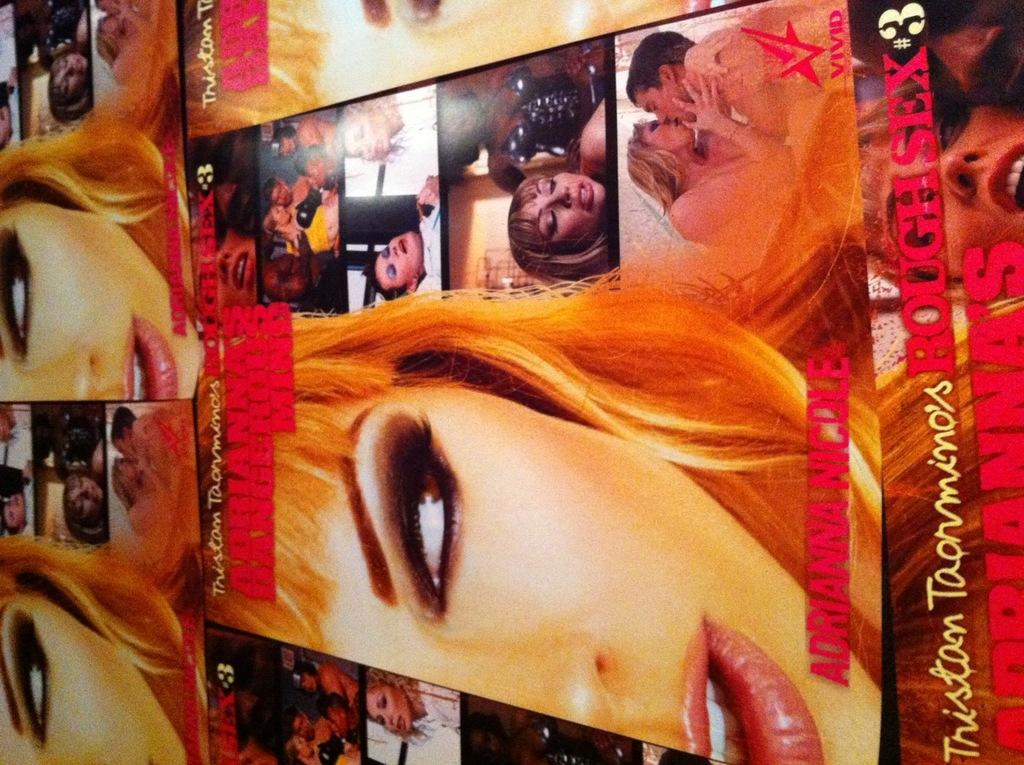<image>
Summarize the visual content of the image. the word mind is on a magazine cover 